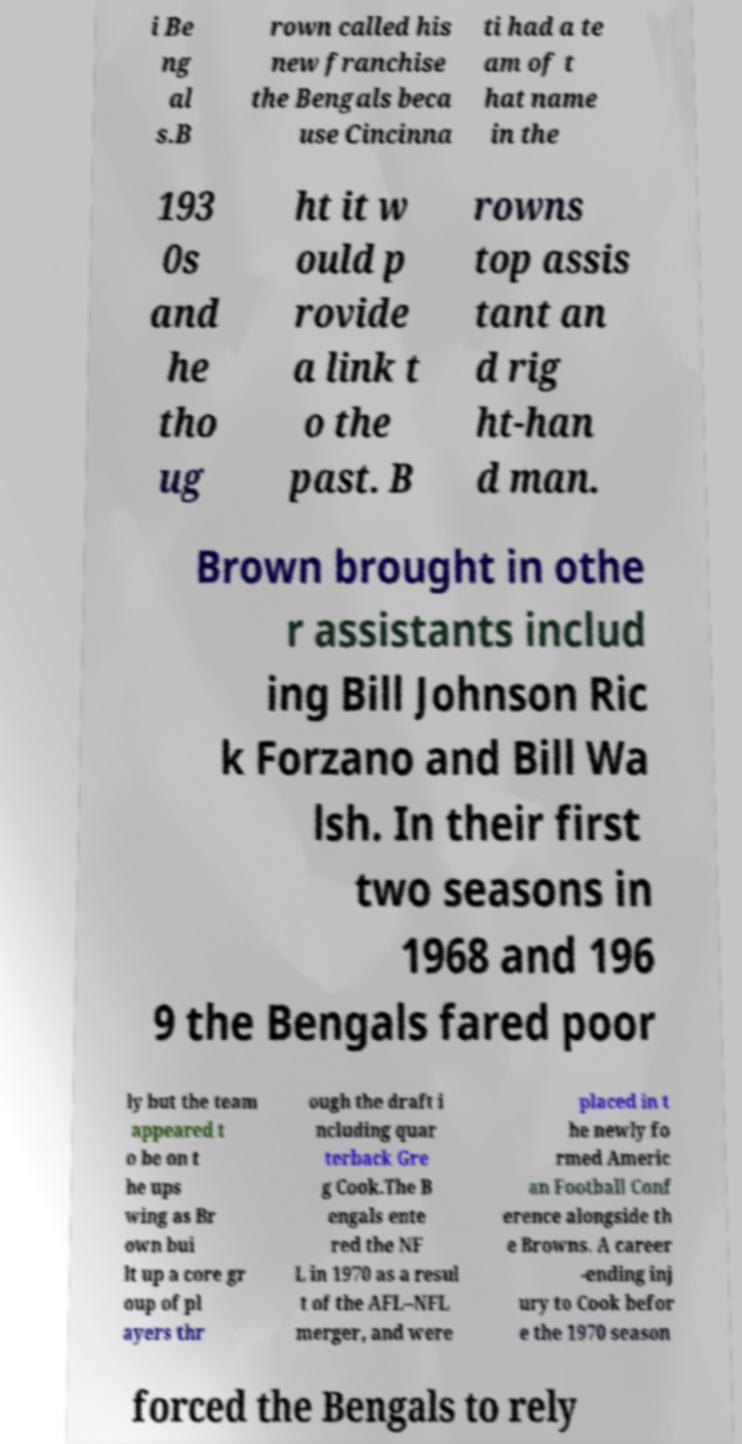Could you assist in decoding the text presented in this image and type it out clearly? i Be ng al s.B rown called his new franchise the Bengals beca use Cincinna ti had a te am of t hat name in the 193 0s and he tho ug ht it w ould p rovide a link t o the past. B rowns top assis tant an d rig ht-han d man. Brown brought in othe r assistants includ ing Bill Johnson Ric k Forzano and Bill Wa lsh. In their first two seasons in 1968 and 196 9 the Bengals fared poor ly but the team appeared t o be on t he ups wing as Br own bui lt up a core gr oup of pl ayers thr ough the draft i ncluding quar terback Gre g Cook.The B engals ente red the NF L in 1970 as a resul t of the AFL–NFL merger, and were placed in t he newly fo rmed Americ an Football Conf erence alongside th e Browns. A career -ending inj ury to Cook befor e the 1970 season forced the Bengals to rely 